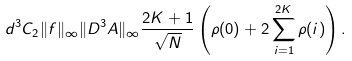Convert formula to latex. <formula><loc_0><loc_0><loc_500><loc_500>d ^ { 3 } C _ { 2 } \| f \| _ { \infty } \| D ^ { 3 } A \| _ { \infty } \frac { 2 K + 1 } { \sqrt { N } } \left ( \rho ( 0 ) + 2 \sum _ { i = 1 } ^ { 2 K } \rho ( i ) \right ) .</formula> 